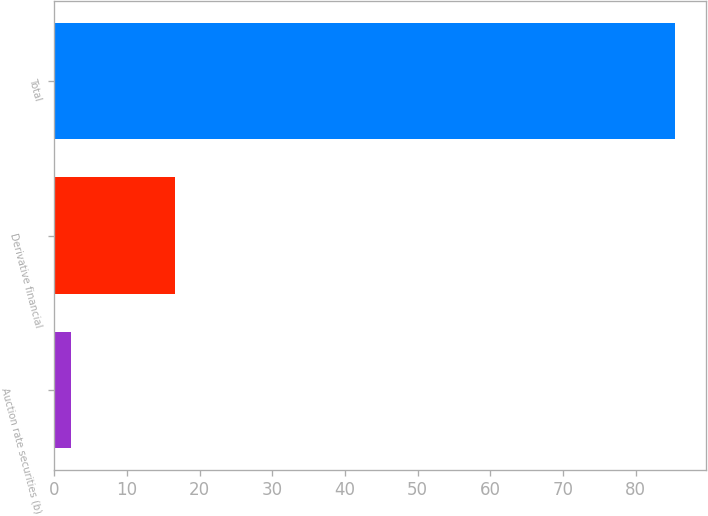Convert chart. <chart><loc_0><loc_0><loc_500><loc_500><bar_chart><fcel>Auction rate securities (b)<fcel>Derivative financial<fcel>Total<nl><fcel>2.3<fcel>16.6<fcel>85.4<nl></chart> 